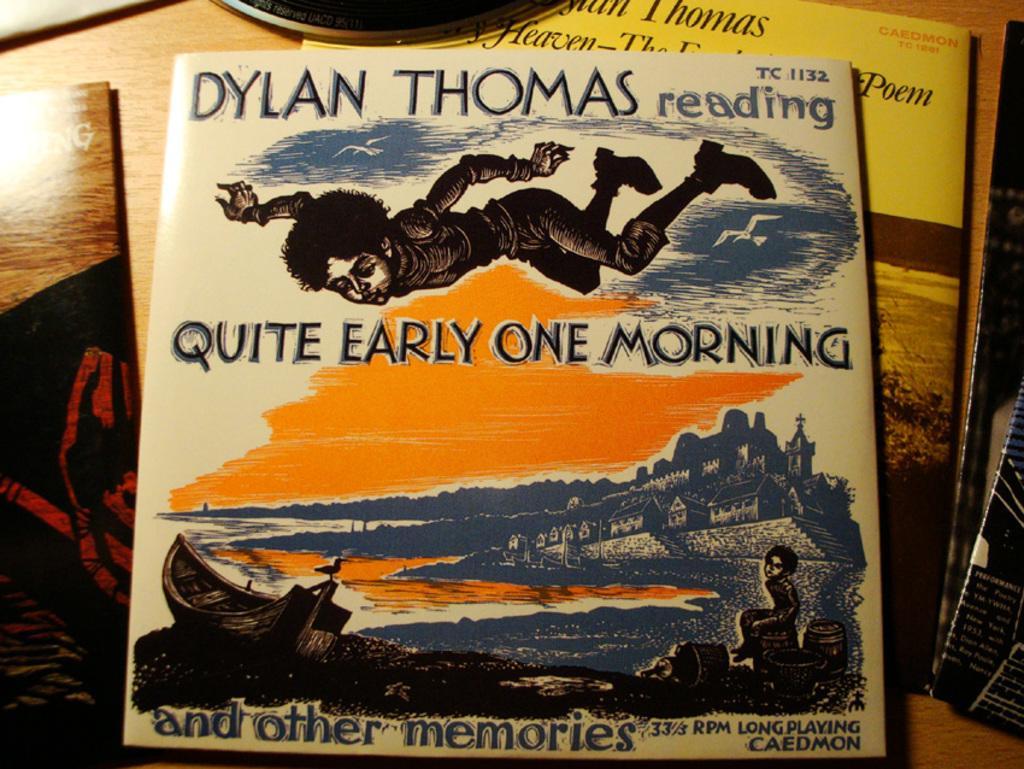Describe this image in one or two sentences. In this image we can see books on the table. 